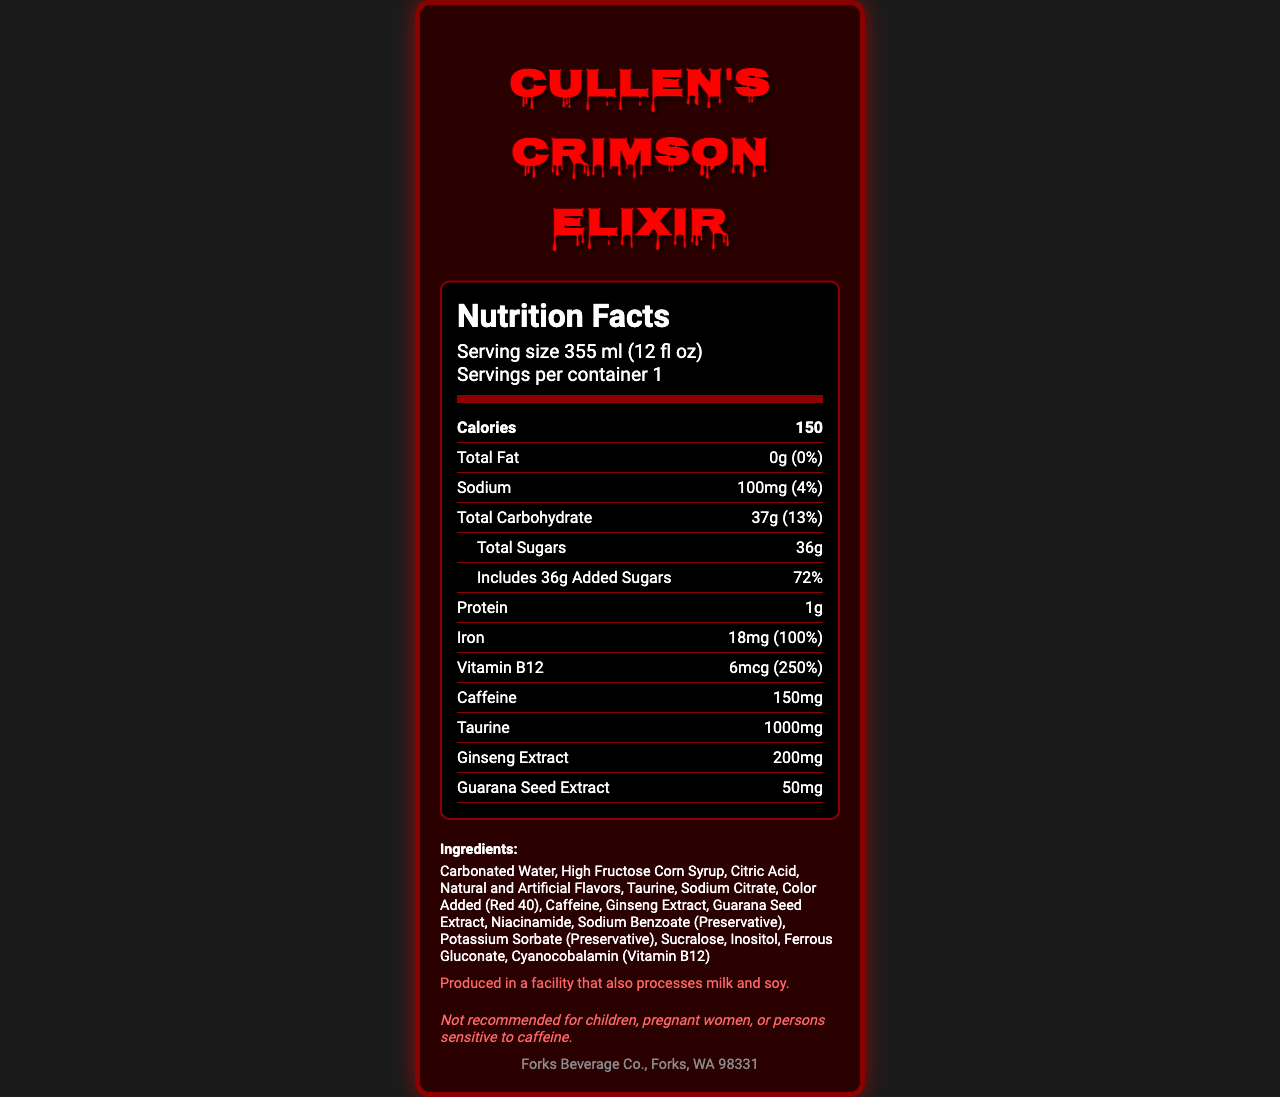what is the serving size of Cullen's Crimson Elixir? The serving size is specified at the beginning of the Nutrition Facts label.
Answer: 355 ml (12 fl oz) how many calories are there per serving? The calorie count is listed directly under the "Nutrition Facts" heading.
Answer: 150 what is the daily value percentage for total fat? The daily value percentage for total fat is listed as 0% next to the total fat amount.
Answer: 0% how much sodium is in the energy drink per serving? The amount of sodium per serving is listed as 100mg.
Answer: 100mg what percentage of the daily value does the added sugars constitute? The added sugars' daily value percentage is shown just below the total sugars amount.
Answer: 72% how much vitamin B12 does Cullen's Crimson Elixir contain? The amount of vitamin B12 is listed as 6mcg.
Answer: 6mcg how much iron is in the energy drink? The total iron content is listed as 18mg.
Answer: 18mg how much taurine is included in the drink? The amount of taurine in the drink is specified as 1000mg.
Answer: 1000mg which ingredient is listed first in the ingredients list? The ingredients list starts with "Carbonated Water."
Answer: Carbonated Water is Cullen's Crimson Elixir recommended for children? The disclaimer states that it is not recommended for children.
Answer: No what is the primary color used in the design of the drink's label? The design elements such as border and text color are described as utilizing shades of red.
Answer: Red who is the distributor for Cullen's Crimson Elixir? A. Forks Beverage Co. B. Twilight Beverage Inc. C. Cullen Enterprises The distributor is specified as Forks Beverage Co., located in Forks, WA.
Answer: A. Forks Beverage Co. what is the serving size per container? A. 250 ml B. 355 ml C. 400 ml The serving size per container is listed as 355 ml (12 fl oz).
Answer: B. 355 ml is Cullen's Crimson Elixir suitable for people sensitive to caffeine? The disclaimer states that it is not recommended for persons sensitive to caffeine.
Answer: No summarize the main components and nutritional information of Cullen's Crimson Elixir. This includes both nutrient quantities and specific ingredients, along with disclaimers.
Answer: Cullen's Crimson Elixir is a 355 ml (12 fl oz) energy drink with 150 calories per serving. It contains 0g total fat, 100mg sodium, 37g total carbohydrate, 36g total sugars (72% daily value of added sugars), 1g protein, 18mg iron (100% daily value), 6mcg vitamin B12 (250% daily value). Additionally, it has 150mg caffeine, 1000mg taurine, 200mg ginseng extract, and 50mg guarana seed extract. The drink contains a variety of ingredients including carbonated water and high fructose corn syrup, and is produced in a facility that processes milk and soy. It is not recommended for children or pregnant women. how much sugar is naturally occurring in the drink? The document only specifies the total sugars and added sugars but does not differentiate naturally occurring sugars.
Answer: Not enough information 